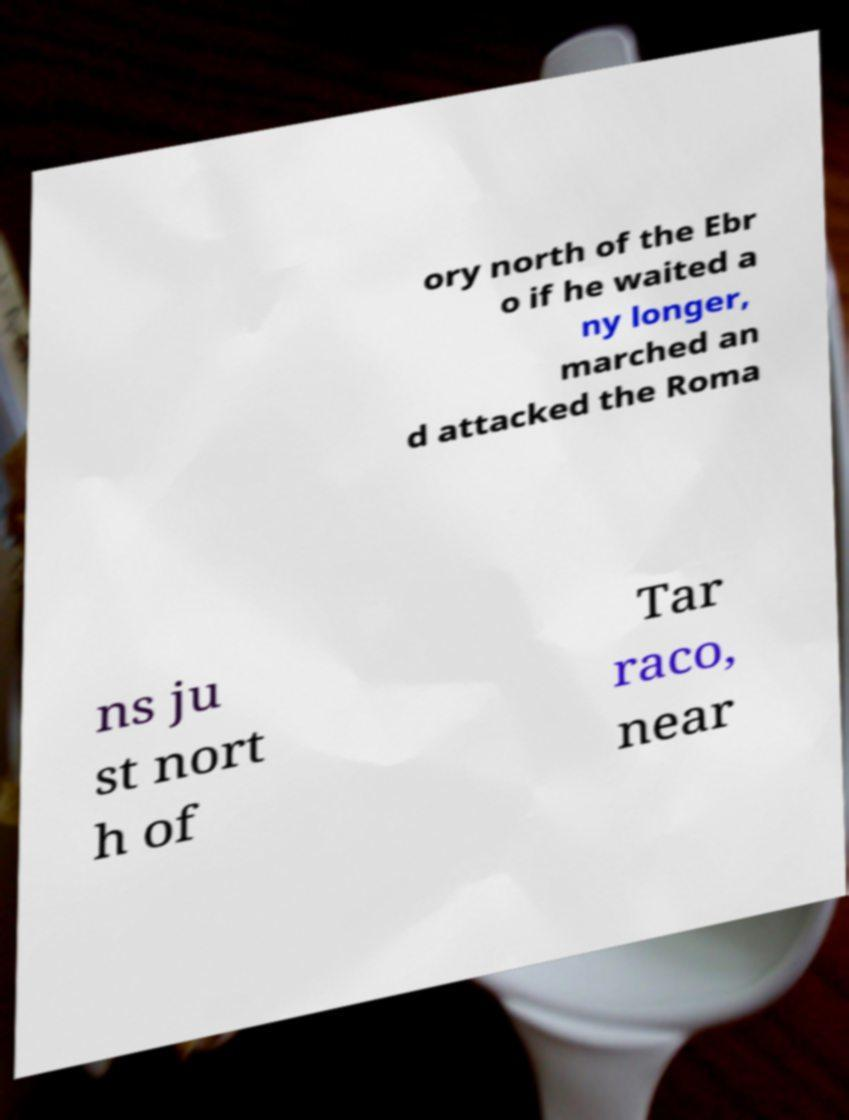For documentation purposes, I need the text within this image transcribed. Could you provide that? ory north of the Ebr o if he waited a ny longer, marched an d attacked the Roma ns ju st nort h of Tar raco, near 